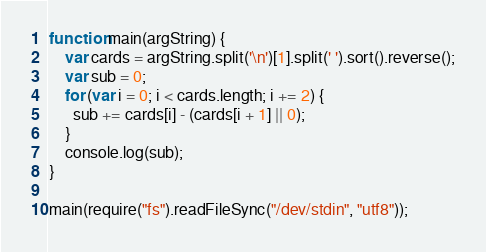<code> <loc_0><loc_0><loc_500><loc_500><_JavaScript_>function main(argString) {
	var cards = argString.split('\n')[1].split(' ').sort().reverse();
  	var sub = 0;
  	for (var i = 0; i < cards.length; i += 2) {
      sub += cards[i] - (cards[i + 1] || 0);
    }
  	console.log(sub);
}

main(require("fs").readFileSync("/dev/stdin", "utf8"));
</code> 